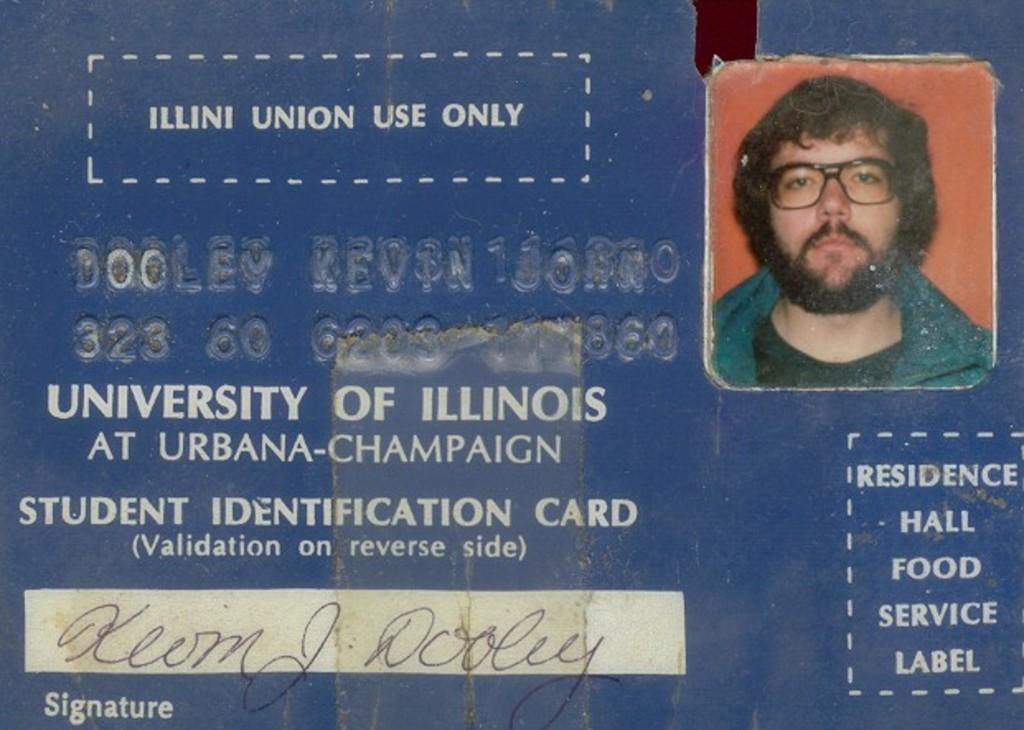What is the main object in the image? There is a student identification card in the image. What can be seen on the card? The card has a photo of a person. What is the person in the photo wearing? The person in the photo is wearing a green jacket and a black T-shirt. What story does the river tell in the image? There is no river present in the image, so it cannot tell a story. 